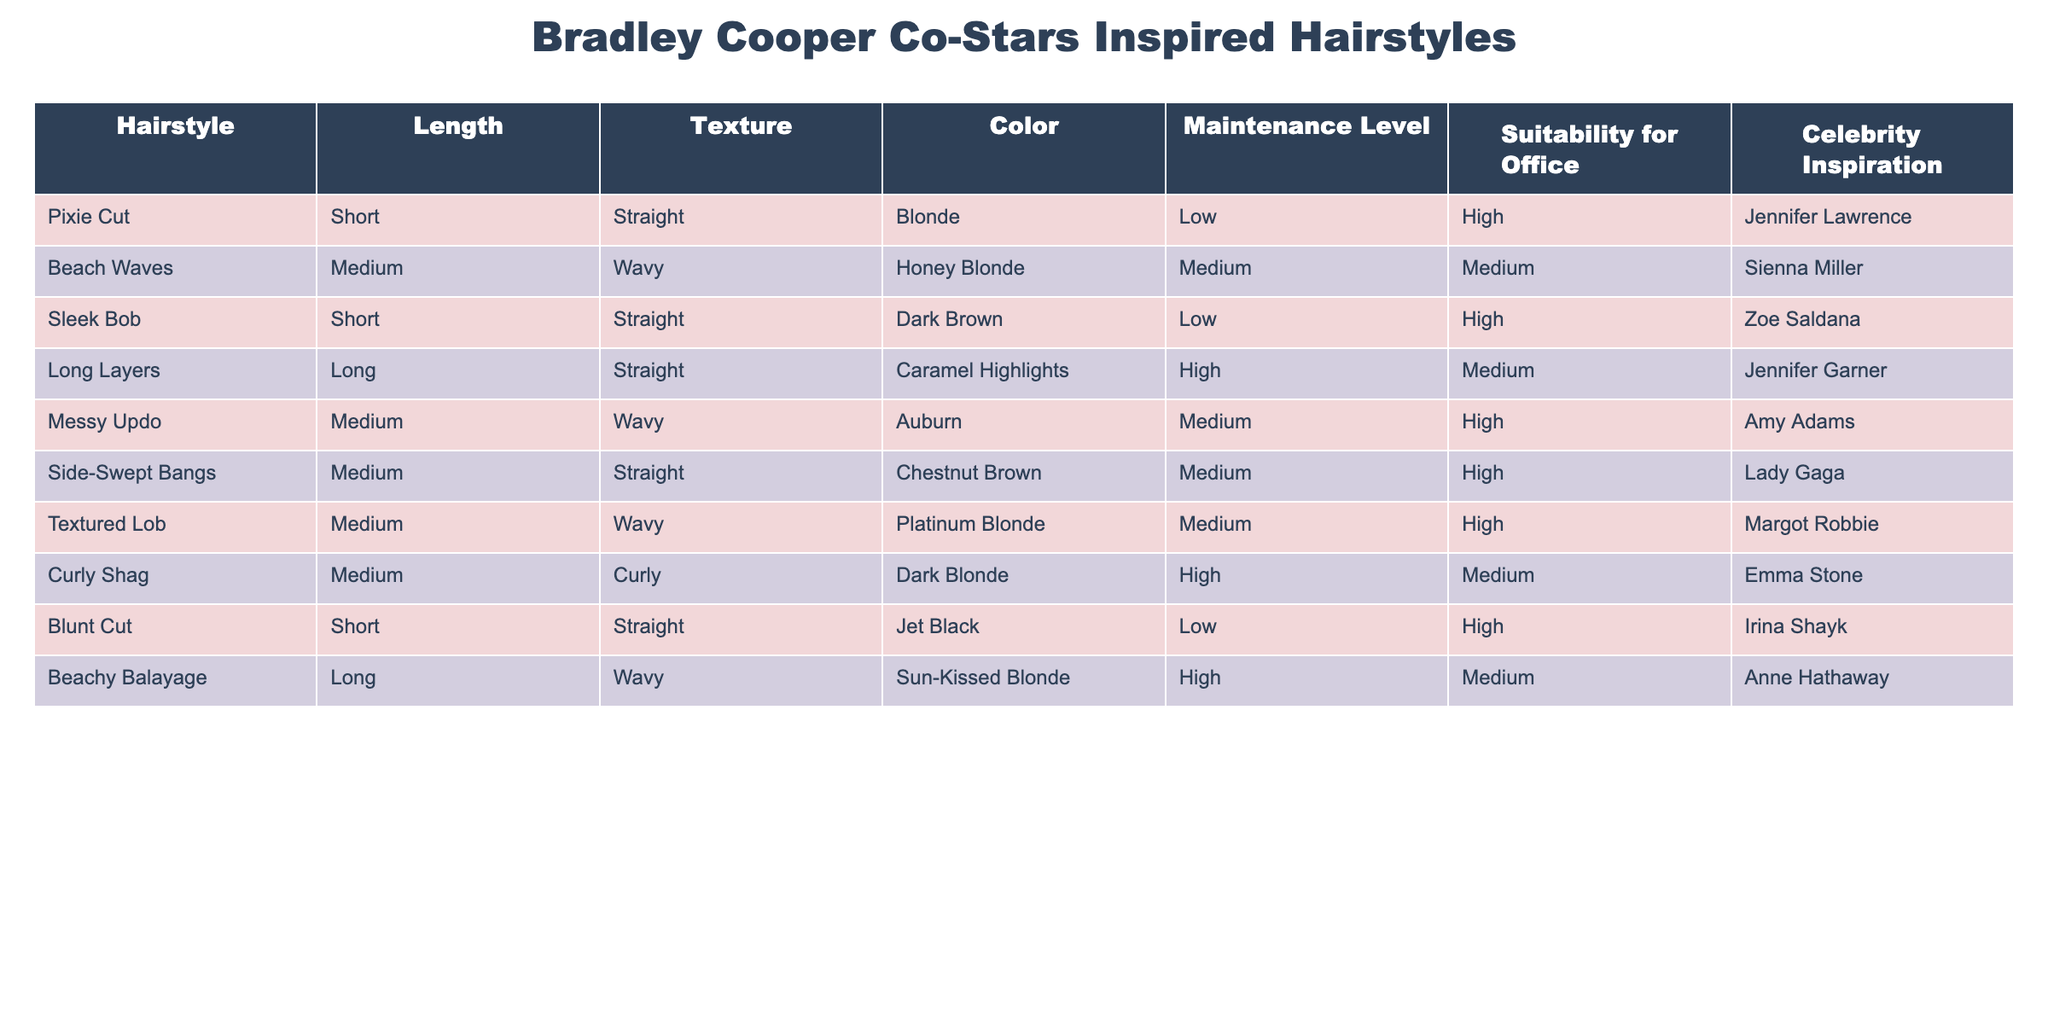What hairstyle has the highest maintenance level? The hairstyle with the highest maintenance level is Long Layers, which has a maintenance level of High. I found this by scanning the Maintenance Level column and identifying the hairstyle that is labeled as High.
Answer: Long Layers Which hairstyles are suitable for the office? The hairstyles that are suitable for the office are Pixie Cut, Sleek Bob, Messy Updo, Side-Swept Bangs, Blunt Cut, and Textured Lob. I determined this by looking at the Suitability for Office column and selecting the hairstyles marked as High.
Answer: Pixie Cut, Sleek Bob, Messy Updo, Side-Swept Bangs, Blunt Cut, Textured Lob How many different hair lengths are represented in the table? There are three distinct hair lengths represented: Short, Medium, and Long. I identified the lengths listed in the Length column and counted them, ensuring there are no duplicates.
Answer: Three Is the Curly Shag hairstyle suitable for the office? No, the Curly Shag hairstyle is not suitable for the office because it has a Suitability for Office rating of Medium. I checked this by looking at the Suitability for Office column for the Curly Shag entry.
Answer: No What is the average maintenance level for Medium-length hairstyles? To find the average, I first count the Medium-length hairstyles, which are Beach Waves, Messy Updo, Side-Swept Bangs, Textured Lob, and Curly Shag, totaling 5. Their maintenance levels are Medium (2x) and High (3x). This translates to 2 for Medium and 3 for High. I assign the numerical values of 1 (Low), 2 (Medium), and 3 (High) to find their total: (2 + 2 + 2 + 3 + 3) = 12, then divide by 5 (number of Medium hairstyles), which gives 12/5 = 2.4, indicating the average is around Medium.
Answer: Medium Which celebrity inspiration is associated with the Jet Black hairstyle? The celebrity associated with the Jet Black hairstyle, which is a Blunt Cut, is Irina Shayk. I found this by checking the Celebrity Inspiration column for the hairstyle that has a color listed as Jet Black.
Answer: Irina Shayk 